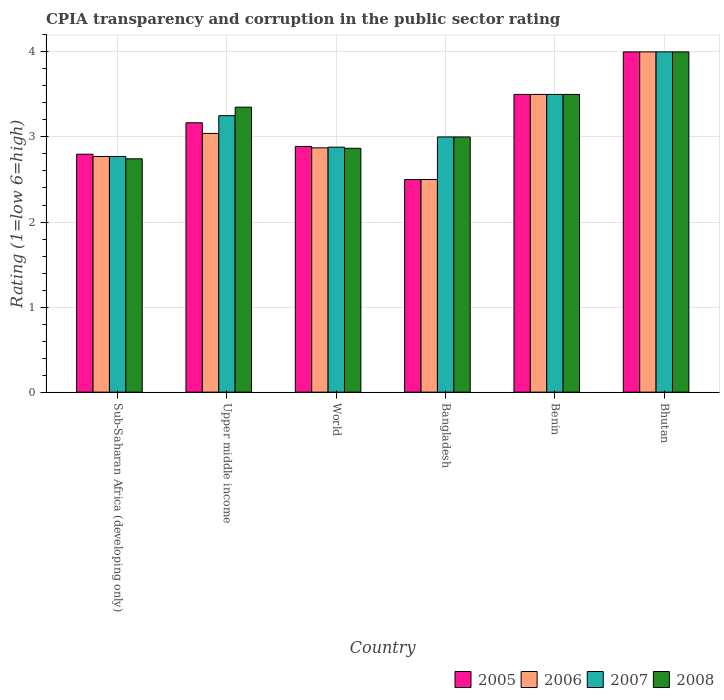How many different coloured bars are there?
Make the answer very short. 4. Are the number of bars per tick equal to the number of legend labels?
Your answer should be compact. Yes. How many bars are there on the 6th tick from the right?
Provide a succinct answer. 4. In how many cases, is the number of bars for a given country not equal to the number of legend labels?
Your response must be concise. 0. What is the CPIA rating in 2006 in World?
Your answer should be compact. 2.87. Across all countries, what is the minimum CPIA rating in 2006?
Your answer should be very brief. 2.5. In which country was the CPIA rating in 2006 maximum?
Your answer should be very brief. Bhutan. In which country was the CPIA rating in 2008 minimum?
Give a very brief answer. Sub-Saharan Africa (developing only). What is the total CPIA rating in 2007 in the graph?
Make the answer very short. 19.4. What is the difference between the CPIA rating in 2007 in Benin and that in Sub-Saharan Africa (developing only)?
Your answer should be very brief. 0.73. What is the average CPIA rating in 2006 per country?
Keep it short and to the point. 3.11. What is the difference between the CPIA rating of/in 2005 and CPIA rating of/in 2007 in Sub-Saharan Africa (developing only)?
Offer a very short reply. 0.03. What is the ratio of the CPIA rating in 2007 in Bangladesh to that in Benin?
Offer a very short reply. 0.86. What is the difference between the highest and the second highest CPIA rating in 2005?
Ensure brevity in your answer.  -0.33. What is the difference between the highest and the lowest CPIA rating in 2007?
Offer a very short reply. 1.23. Is it the case that in every country, the sum of the CPIA rating in 2006 and CPIA rating in 2008 is greater than the sum of CPIA rating in 2007 and CPIA rating in 2005?
Your response must be concise. No. What does the 3rd bar from the right in Sub-Saharan Africa (developing only) represents?
Provide a succinct answer. 2006. What is the difference between two consecutive major ticks on the Y-axis?
Provide a succinct answer. 1. Does the graph contain any zero values?
Your answer should be very brief. No. What is the title of the graph?
Your answer should be compact. CPIA transparency and corruption in the public sector rating. What is the label or title of the X-axis?
Ensure brevity in your answer.  Country. What is the label or title of the Y-axis?
Provide a succinct answer. Rating (1=low 6=high). What is the Rating (1=low 6=high) of 2005 in Sub-Saharan Africa (developing only)?
Give a very brief answer. 2.8. What is the Rating (1=low 6=high) of 2006 in Sub-Saharan Africa (developing only)?
Give a very brief answer. 2.77. What is the Rating (1=low 6=high) in 2007 in Sub-Saharan Africa (developing only)?
Give a very brief answer. 2.77. What is the Rating (1=low 6=high) in 2008 in Sub-Saharan Africa (developing only)?
Provide a short and direct response. 2.74. What is the Rating (1=low 6=high) in 2005 in Upper middle income?
Offer a very short reply. 3.17. What is the Rating (1=low 6=high) of 2006 in Upper middle income?
Offer a very short reply. 3.04. What is the Rating (1=low 6=high) of 2007 in Upper middle income?
Ensure brevity in your answer.  3.25. What is the Rating (1=low 6=high) in 2008 in Upper middle income?
Provide a short and direct response. 3.35. What is the Rating (1=low 6=high) of 2005 in World?
Keep it short and to the point. 2.89. What is the Rating (1=low 6=high) of 2006 in World?
Your answer should be very brief. 2.87. What is the Rating (1=low 6=high) of 2007 in World?
Your answer should be very brief. 2.88. What is the Rating (1=low 6=high) of 2008 in World?
Offer a terse response. 2.87. What is the Rating (1=low 6=high) in 2006 in Bangladesh?
Provide a succinct answer. 2.5. What is the Rating (1=low 6=high) of 2006 in Benin?
Ensure brevity in your answer.  3.5. What is the Rating (1=low 6=high) in 2008 in Benin?
Offer a very short reply. 3.5. What is the Rating (1=low 6=high) in 2006 in Bhutan?
Give a very brief answer. 4. Across all countries, what is the maximum Rating (1=low 6=high) in 2005?
Offer a terse response. 4. Across all countries, what is the maximum Rating (1=low 6=high) of 2007?
Provide a short and direct response. 4. Across all countries, what is the minimum Rating (1=low 6=high) in 2005?
Make the answer very short. 2.5. Across all countries, what is the minimum Rating (1=low 6=high) of 2007?
Offer a terse response. 2.77. Across all countries, what is the minimum Rating (1=low 6=high) in 2008?
Your response must be concise. 2.74. What is the total Rating (1=low 6=high) of 2005 in the graph?
Ensure brevity in your answer.  18.85. What is the total Rating (1=low 6=high) of 2006 in the graph?
Ensure brevity in your answer.  18.68. What is the total Rating (1=low 6=high) of 2007 in the graph?
Keep it short and to the point. 19.4. What is the total Rating (1=low 6=high) in 2008 in the graph?
Keep it short and to the point. 19.46. What is the difference between the Rating (1=low 6=high) of 2005 in Sub-Saharan Africa (developing only) and that in Upper middle income?
Your answer should be compact. -0.37. What is the difference between the Rating (1=low 6=high) in 2006 in Sub-Saharan Africa (developing only) and that in Upper middle income?
Ensure brevity in your answer.  -0.27. What is the difference between the Rating (1=low 6=high) in 2007 in Sub-Saharan Africa (developing only) and that in Upper middle income?
Your answer should be compact. -0.48. What is the difference between the Rating (1=low 6=high) of 2008 in Sub-Saharan Africa (developing only) and that in Upper middle income?
Your response must be concise. -0.61. What is the difference between the Rating (1=low 6=high) in 2005 in Sub-Saharan Africa (developing only) and that in World?
Offer a terse response. -0.09. What is the difference between the Rating (1=low 6=high) in 2006 in Sub-Saharan Africa (developing only) and that in World?
Provide a short and direct response. -0.1. What is the difference between the Rating (1=low 6=high) in 2007 in Sub-Saharan Africa (developing only) and that in World?
Your answer should be compact. -0.11. What is the difference between the Rating (1=low 6=high) in 2008 in Sub-Saharan Africa (developing only) and that in World?
Your answer should be very brief. -0.12. What is the difference between the Rating (1=low 6=high) in 2005 in Sub-Saharan Africa (developing only) and that in Bangladesh?
Your answer should be very brief. 0.3. What is the difference between the Rating (1=low 6=high) in 2006 in Sub-Saharan Africa (developing only) and that in Bangladesh?
Your answer should be compact. 0.27. What is the difference between the Rating (1=low 6=high) in 2007 in Sub-Saharan Africa (developing only) and that in Bangladesh?
Provide a short and direct response. -0.23. What is the difference between the Rating (1=low 6=high) of 2008 in Sub-Saharan Africa (developing only) and that in Bangladesh?
Ensure brevity in your answer.  -0.26. What is the difference between the Rating (1=low 6=high) in 2005 in Sub-Saharan Africa (developing only) and that in Benin?
Your answer should be very brief. -0.7. What is the difference between the Rating (1=low 6=high) of 2006 in Sub-Saharan Africa (developing only) and that in Benin?
Provide a short and direct response. -0.73. What is the difference between the Rating (1=low 6=high) of 2007 in Sub-Saharan Africa (developing only) and that in Benin?
Give a very brief answer. -0.73. What is the difference between the Rating (1=low 6=high) of 2008 in Sub-Saharan Africa (developing only) and that in Benin?
Your answer should be compact. -0.76. What is the difference between the Rating (1=low 6=high) of 2005 in Sub-Saharan Africa (developing only) and that in Bhutan?
Your answer should be very brief. -1.2. What is the difference between the Rating (1=low 6=high) of 2006 in Sub-Saharan Africa (developing only) and that in Bhutan?
Provide a succinct answer. -1.23. What is the difference between the Rating (1=low 6=high) of 2007 in Sub-Saharan Africa (developing only) and that in Bhutan?
Keep it short and to the point. -1.23. What is the difference between the Rating (1=low 6=high) in 2008 in Sub-Saharan Africa (developing only) and that in Bhutan?
Your response must be concise. -1.26. What is the difference between the Rating (1=low 6=high) in 2005 in Upper middle income and that in World?
Ensure brevity in your answer.  0.28. What is the difference between the Rating (1=low 6=high) in 2006 in Upper middle income and that in World?
Your response must be concise. 0.17. What is the difference between the Rating (1=low 6=high) of 2007 in Upper middle income and that in World?
Keep it short and to the point. 0.37. What is the difference between the Rating (1=low 6=high) in 2008 in Upper middle income and that in World?
Provide a succinct answer. 0.48. What is the difference between the Rating (1=low 6=high) in 2005 in Upper middle income and that in Bangladesh?
Keep it short and to the point. 0.67. What is the difference between the Rating (1=low 6=high) in 2006 in Upper middle income and that in Bangladesh?
Your response must be concise. 0.54. What is the difference between the Rating (1=low 6=high) in 2007 in Upper middle income and that in Bangladesh?
Provide a short and direct response. 0.25. What is the difference between the Rating (1=low 6=high) in 2008 in Upper middle income and that in Bangladesh?
Offer a terse response. 0.35. What is the difference between the Rating (1=low 6=high) of 2006 in Upper middle income and that in Benin?
Offer a terse response. -0.46. What is the difference between the Rating (1=low 6=high) of 2006 in Upper middle income and that in Bhutan?
Give a very brief answer. -0.96. What is the difference between the Rating (1=low 6=high) of 2007 in Upper middle income and that in Bhutan?
Provide a succinct answer. -0.75. What is the difference between the Rating (1=low 6=high) in 2008 in Upper middle income and that in Bhutan?
Make the answer very short. -0.65. What is the difference between the Rating (1=low 6=high) of 2005 in World and that in Bangladesh?
Ensure brevity in your answer.  0.39. What is the difference between the Rating (1=low 6=high) of 2006 in World and that in Bangladesh?
Your response must be concise. 0.37. What is the difference between the Rating (1=low 6=high) of 2007 in World and that in Bangladesh?
Provide a succinct answer. -0.12. What is the difference between the Rating (1=low 6=high) of 2008 in World and that in Bangladesh?
Provide a short and direct response. -0.13. What is the difference between the Rating (1=low 6=high) in 2005 in World and that in Benin?
Offer a very short reply. -0.61. What is the difference between the Rating (1=low 6=high) in 2006 in World and that in Benin?
Provide a short and direct response. -0.63. What is the difference between the Rating (1=low 6=high) of 2007 in World and that in Benin?
Offer a very short reply. -0.62. What is the difference between the Rating (1=low 6=high) of 2008 in World and that in Benin?
Give a very brief answer. -0.63. What is the difference between the Rating (1=low 6=high) in 2005 in World and that in Bhutan?
Ensure brevity in your answer.  -1.11. What is the difference between the Rating (1=low 6=high) of 2006 in World and that in Bhutan?
Give a very brief answer. -1.13. What is the difference between the Rating (1=low 6=high) in 2007 in World and that in Bhutan?
Give a very brief answer. -1.12. What is the difference between the Rating (1=low 6=high) in 2008 in World and that in Bhutan?
Ensure brevity in your answer.  -1.13. What is the difference between the Rating (1=low 6=high) in 2005 in Bangladesh and that in Benin?
Make the answer very short. -1. What is the difference between the Rating (1=low 6=high) in 2006 in Bangladesh and that in Benin?
Offer a terse response. -1. What is the difference between the Rating (1=low 6=high) of 2007 in Bangladesh and that in Benin?
Offer a terse response. -0.5. What is the difference between the Rating (1=low 6=high) in 2008 in Bangladesh and that in Benin?
Ensure brevity in your answer.  -0.5. What is the difference between the Rating (1=low 6=high) of 2008 in Bangladesh and that in Bhutan?
Offer a very short reply. -1. What is the difference between the Rating (1=low 6=high) in 2006 in Benin and that in Bhutan?
Offer a very short reply. -0.5. What is the difference between the Rating (1=low 6=high) of 2008 in Benin and that in Bhutan?
Give a very brief answer. -0.5. What is the difference between the Rating (1=low 6=high) in 2005 in Sub-Saharan Africa (developing only) and the Rating (1=low 6=high) in 2006 in Upper middle income?
Provide a succinct answer. -0.24. What is the difference between the Rating (1=low 6=high) of 2005 in Sub-Saharan Africa (developing only) and the Rating (1=low 6=high) of 2007 in Upper middle income?
Your answer should be compact. -0.45. What is the difference between the Rating (1=low 6=high) in 2005 in Sub-Saharan Africa (developing only) and the Rating (1=low 6=high) in 2008 in Upper middle income?
Your answer should be very brief. -0.55. What is the difference between the Rating (1=low 6=high) in 2006 in Sub-Saharan Africa (developing only) and the Rating (1=low 6=high) in 2007 in Upper middle income?
Your response must be concise. -0.48. What is the difference between the Rating (1=low 6=high) in 2006 in Sub-Saharan Africa (developing only) and the Rating (1=low 6=high) in 2008 in Upper middle income?
Make the answer very short. -0.58. What is the difference between the Rating (1=low 6=high) in 2007 in Sub-Saharan Africa (developing only) and the Rating (1=low 6=high) in 2008 in Upper middle income?
Ensure brevity in your answer.  -0.58. What is the difference between the Rating (1=low 6=high) in 2005 in Sub-Saharan Africa (developing only) and the Rating (1=low 6=high) in 2006 in World?
Ensure brevity in your answer.  -0.07. What is the difference between the Rating (1=low 6=high) of 2005 in Sub-Saharan Africa (developing only) and the Rating (1=low 6=high) of 2007 in World?
Make the answer very short. -0.08. What is the difference between the Rating (1=low 6=high) in 2005 in Sub-Saharan Africa (developing only) and the Rating (1=low 6=high) in 2008 in World?
Your answer should be very brief. -0.07. What is the difference between the Rating (1=low 6=high) in 2006 in Sub-Saharan Africa (developing only) and the Rating (1=low 6=high) in 2007 in World?
Offer a terse response. -0.11. What is the difference between the Rating (1=low 6=high) in 2006 in Sub-Saharan Africa (developing only) and the Rating (1=low 6=high) in 2008 in World?
Provide a succinct answer. -0.1. What is the difference between the Rating (1=low 6=high) of 2007 in Sub-Saharan Africa (developing only) and the Rating (1=low 6=high) of 2008 in World?
Your answer should be compact. -0.1. What is the difference between the Rating (1=low 6=high) of 2005 in Sub-Saharan Africa (developing only) and the Rating (1=low 6=high) of 2006 in Bangladesh?
Keep it short and to the point. 0.3. What is the difference between the Rating (1=low 6=high) of 2005 in Sub-Saharan Africa (developing only) and the Rating (1=low 6=high) of 2007 in Bangladesh?
Ensure brevity in your answer.  -0.2. What is the difference between the Rating (1=low 6=high) in 2005 in Sub-Saharan Africa (developing only) and the Rating (1=low 6=high) in 2008 in Bangladesh?
Give a very brief answer. -0.2. What is the difference between the Rating (1=low 6=high) in 2006 in Sub-Saharan Africa (developing only) and the Rating (1=low 6=high) in 2007 in Bangladesh?
Your answer should be compact. -0.23. What is the difference between the Rating (1=low 6=high) of 2006 in Sub-Saharan Africa (developing only) and the Rating (1=low 6=high) of 2008 in Bangladesh?
Provide a succinct answer. -0.23. What is the difference between the Rating (1=low 6=high) in 2007 in Sub-Saharan Africa (developing only) and the Rating (1=low 6=high) in 2008 in Bangladesh?
Give a very brief answer. -0.23. What is the difference between the Rating (1=low 6=high) in 2005 in Sub-Saharan Africa (developing only) and the Rating (1=low 6=high) in 2006 in Benin?
Your response must be concise. -0.7. What is the difference between the Rating (1=low 6=high) in 2005 in Sub-Saharan Africa (developing only) and the Rating (1=low 6=high) in 2007 in Benin?
Offer a terse response. -0.7. What is the difference between the Rating (1=low 6=high) in 2005 in Sub-Saharan Africa (developing only) and the Rating (1=low 6=high) in 2008 in Benin?
Offer a very short reply. -0.7. What is the difference between the Rating (1=low 6=high) in 2006 in Sub-Saharan Africa (developing only) and the Rating (1=low 6=high) in 2007 in Benin?
Your response must be concise. -0.73. What is the difference between the Rating (1=low 6=high) of 2006 in Sub-Saharan Africa (developing only) and the Rating (1=low 6=high) of 2008 in Benin?
Provide a short and direct response. -0.73. What is the difference between the Rating (1=low 6=high) of 2007 in Sub-Saharan Africa (developing only) and the Rating (1=low 6=high) of 2008 in Benin?
Provide a succinct answer. -0.73. What is the difference between the Rating (1=low 6=high) in 2005 in Sub-Saharan Africa (developing only) and the Rating (1=low 6=high) in 2006 in Bhutan?
Give a very brief answer. -1.2. What is the difference between the Rating (1=low 6=high) in 2005 in Sub-Saharan Africa (developing only) and the Rating (1=low 6=high) in 2007 in Bhutan?
Offer a terse response. -1.2. What is the difference between the Rating (1=low 6=high) in 2005 in Sub-Saharan Africa (developing only) and the Rating (1=low 6=high) in 2008 in Bhutan?
Your answer should be compact. -1.2. What is the difference between the Rating (1=low 6=high) of 2006 in Sub-Saharan Africa (developing only) and the Rating (1=low 6=high) of 2007 in Bhutan?
Your response must be concise. -1.23. What is the difference between the Rating (1=low 6=high) in 2006 in Sub-Saharan Africa (developing only) and the Rating (1=low 6=high) in 2008 in Bhutan?
Give a very brief answer. -1.23. What is the difference between the Rating (1=low 6=high) of 2007 in Sub-Saharan Africa (developing only) and the Rating (1=low 6=high) of 2008 in Bhutan?
Provide a succinct answer. -1.23. What is the difference between the Rating (1=low 6=high) in 2005 in Upper middle income and the Rating (1=low 6=high) in 2006 in World?
Keep it short and to the point. 0.29. What is the difference between the Rating (1=low 6=high) in 2005 in Upper middle income and the Rating (1=low 6=high) in 2007 in World?
Give a very brief answer. 0.29. What is the difference between the Rating (1=low 6=high) of 2006 in Upper middle income and the Rating (1=low 6=high) of 2007 in World?
Offer a very short reply. 0.16. What is the difference between the Rating (1=low 6=high) of 2006 in Upper middle income and the Rating (1=low 6=high) of 2008 in World?
Your response must be concise. 0.17. What is the difference between the Rating (1=low 6=high) of 2007 in Upper middle income and the Rating (1=low 6=high) of 2008 in World?
Ensure brevity in your answer.  0.38. What is the difference between the Rating (1=low 6=high) of 2005 in Upper middle income and the Rating (1=low 6=high) of 2006 in Bangladesh?
Make the answer very short. 0.67. What is the difference between the Rating (1=low 6=high) in 2005 in Upper middle income and the Rating (1=low 6=high) in 2008 in Bangladesh?
Offer a terse response. 0.17. What is the difference between the Rating (1=low 6=high) in 2006 in Upper middle income and the Rating (1=low 6=high) in 2007 in Bangladesh?
Your answer should be very brief. 0.04. What is the difference between the Rating (1=low 6=high) in 2006 in Upper middle income and the Rating (1=low 6=high) in 2008 in Bangladesh?
Provide a succinct answer. 0.04. What is the difference between the Rating (1=low 6=high) of 2007 in Upper middle income and the Rating (1=low 6=high) of 2008 in Bangladesh?
Offer a very short reply. 0.25. What is the difference between the Rating (1=low 6=high) in 2005 in Upper middle income and the Rating (1=low 6=high) in 2006 in Benin?
Your answer should be compact. -0.33. What is the difference between the Rating (1=low 6=high) in 2005 in Upper middle income and the Rating (1=low 6=high) in 2007 in Benin?
Offer a terse response. -0.33. What is the difference between the Rating (1=low 6=high) in 2006 in Upper middle income and the Rating (1=low 6=high) in 2007 in Benin?
Provide a short and direct response. -0.46. What is the difference between the Rating (1=low 6=high) of 2006 in Upper middle income and the Rating (1=low 6=high) of 2008 in Benin?
Offer a terse response. -0.46. What is the difference between the Rating (1=low 6=high) of 2005 in Upper middle income and the Rating (1=low 6=high) of 2006 in Bhutan?
Offer a terse response. -0.83. What is the difference between the Rating (1=low 6=high) in 2005 in Upper middle income and the Rating (1=low 6=high) in 2008 in Bhutan?
Offer a terse response. -0.83. What is the difference between the Rating (1=low 6=high) of 2006 in Upper middle income and the Rating (1=low 6=high) of 2007 in Bhutan?
Your answer should be compact. -0.96. What is the difference between the Rating (1=low 6=high) in 2006 in Upper middle income and the Rating (1=low 6=high) in 2008 in Bhutan?
Offer a terse response. -0.96. What is the difference between the Rating (1=low 6=high) in 2007 in Upper middle income and the Rating (1=low 6=high) in 2008 in Bhutan?
Offer a terse response. -0.75. What is the difference between the Rating (1=low 6=high) of 2005 in World and the Rating (1=low 6=high) of 2006 in Bangladesh?
Provide a succinct answer. 0.39. What is the difference between the Rating (1=low 6=high) in 2005 in World and the Rating (1=low 6=high) in 2007 in Bangladesh?
Offer a terse response. -0.11. What is the difference between the Rating (1=low 6=high) in 2005 in World and the Rating (1=low 6=high) in 2008 in Bangladesh?
Offer a terse response. -0.11. What is the difference between the Rating (1=low 6=high) of 2006 in World and the Rating (1=low 6=high) of 2007 in Bangladesh?
Provide a succinct answer. -0.13. What is the difference between the Rating (1=low 6=high) of 2006 in World and the Rating (1=low 6=high) of 2008 in Bangladesh?
Ensure brevity in your answer.  -0.13. What is the difference between the Rating (1=low 6=high) in 2007 in World and the Rating (1=low 6=high) in 2008 in Bangladesh?
Keep it short and to the point. -0.12. What is the difference between the Rating (1=low 6=high) of 2005 in World and the Rating (1=low 6=high) of 2006 in Benin?
Your response must be concise. -0.61. What is the difference between the Rating (1=low 6=high) of 2005 in World and the Rating (1=low 6=high) of 2007 in Benin?
Offer a terse response. -0.61. What is the difference between the Rating (1=low 6=high) in 2005 in World and the Rating (1=low 6=high) in 2008 in Benin?
Give a very brief answer. -0.61. What is the difference between the Rating (1=low 6=high) in 2006 in World and the Rating (1=low 6=high) in 2007 in Benin?
Offer a terse response. -0.63. What is the difference between the Rating (1=low 6=high) of 2006 in World and the Rating (1=low 6=high) of 2008 in Benin?
Provide a short and direct response. -0.63. What is the difference between the Rating (1=low 6=high) in 2007 in World and the Rating (1=low 6=high) in 2008 in Benin?
Keep it short and to the point. -0.62. What is the difference between the Rating (1=low 6=high) in 2005 in World and the Rating (1=low 6=high) in 2006 in Bhutan?
Give a very brief answer. -1.11. What is the difference between the Rating (1=low 6=high) in 2005 in World and the Rating (1=low 6=high) in 2007 in Bhutan?
Offer a terse response. -1.11. What is the difference between the Rating (1=low 6=high) of 2005 in World and the Rating (1=low 6=high) of 2008 in Bhutan?
Offer a very short reply. -1.11. What is the difference between the Rating (1=low 6=high) in 2006 in World and the Rating (1=low 6=high) in 2007 in Bhutan?
Provide a succinct answer. -1.13. What is the difference between the Rating (1=low 6=high) in 2006 in World and the Rating (1=low 6=high) in 2008 in Bhutan?
Provide a succinct answer. -1.13. What is the difference between the Rating (1=low 6=high) of 2007 in World and the Rating (1=low 6=high) of 2008 in Bhutan?
Offer a terse response. -1.12. What is the difference between the Rating (1=low 6=high) in 2005 in Bangladesh and the Rating (1=low 6=high) in 2006 in Benin?
Give a very brief answer. -1. What is the difference between the Rating (1=low 6=high) in 2006 in Bangladesh and the Rating (1=low 6=high) in 2007 in Benin?
Provide a short and direct response. -1. What is the difference between the Rating (1=low 6=high) in 2005 in Bangladesh and the Rating (1=low 6=high) in 2007 in Bhutan?
Keep it short and to the point. -1.5. What is the difference between the Rating (1=low 6=high) in 2006 in Bangladesh and the Rating (1=low 6=high) in 2007 in Bhutan?
Your answer should be compact. -1.5. What is the difference between the Rating (1=low 6=high) of 2006 in Bangladesh and the Rating (1=low 6=high) of 2008 in Bhutan?
Provide a short and direct response. -1.5. What is the difference between the Rating (1=low 6=high) of 2005 in Benin and the Rating (1=low 6=high) of 2006 in Bhutan?
Your answer should be very brief. -0.5. What is the difference between the Rating (1=low 6=high) of 2005 in Benin and the Rating (1=low 6=high) of 2007 in Bhutan?
Provide a short and direct response. -0.5. What is the difference between the Rating (1=low 6=high) in 2005 in Benin and the Rating (1=low 6=high) in 2008 in Bhutan?
Give a very brief answer. -0.5. What is the difference between the Rating (1=low 6=high) in 2006 in Benin and the Rating (1=low 6=high) in 2007 in Bhutan?
Offer a very short reply. -0.5. What is the difference between the Rating (1=low 6=high) in 2006 in Benin and the Rating (1=low 6=high) in 2008 in Bhutan?
Provide a short and direct response. -0.5. What is the difference between the Rating (1=low 6=high) of 2007 in Benin and the Rating (1=low 6=high) of 2008 in Bhutan?
Keep it short and to the point. -0.5. What is the average Rating (1=low 6=high) in 2005 per country?
Offer a terse response. 3.14. What is the average Rating (1=low 6=high) of 2006 per country?
Offer a terse response. 3.11. What is the average Rating (1=low 6=high) of 2007 per country?
Give a very brief answer. 3.23. What is the average Rating (1=low 6=high) of 2008 per country?
Give a very brief answer. 3.24. What is the difference between the Rating (1=low 6=high) of 2005 and Rating (1=low 6=high) of 2006 in Sub-Saharan Africa (developing only)?
Give a very brief answer. 0.03. What is the difference between the Rating (1=low 6=high) of 2005 and Rating (1=low 6=high) of 2007 in Sub-Saharan Africa (developing only)?
Your answer should be compact. 0.03. What is the difference between the Rating (1=low 6=high) in 2005 and Rating (1=low 6=high) in 2008 in Sub-Saharan Africa (developing only)?
Keep it short and to the point. 0.05. What is the difference between the Rating (1=low 6=high) of 2006 and Rating (1=low 6=high) of 2007 in Sub-Saharan Africa (developing only)?
Your answer should be very brief. 0. What is the difference between the Rating (1=low 6=high) of 2006 and Rating (1=low 6=high) of 2008 in Sub-Saharan Africa (developing only)?
Keep it short and to the point. 0.03. What is the difference between the Rating (1=low 6=high) in 2007 and Rating (1=low 6=high) in 2008 in Sub-Saharan Africa (developing only)?
Offer a very short reply. 0.03. What is the difference between the Rating (1=low 6=high) of 2005 and Rating (1=low 6=high) of 2007 in Upper middle income?
Give a very brief answer. -0.08. What is the difference between the Rating (1=low 6=high) of 2005 and Rating (1=low 6=high) of 2008 in Upper middle income?
Offer a terse response. -0.18. What is the difference between the Rating (1=low 6=high) of 2006 and Rating (1=low 6=high) of 2007 in Upper middle income?
Provide a short and direct response. -0.21. What is the difference between the Rating (1=low 6=high) in 2006 and Rating (1=low 6=high) in 2008 in Upper middle income?
Provide a short and direct response. -0.31. What is the difference between the Rating (1=low 6=high) of 2005 and Rating (1=low 6=high) of 2006 in World?
Offer a very short reply. 0.02. What is the difference between the Rating (1=low 6=high) in 2005 and Rating (1=low 6=high) in 2007 in World?
Provide a short and direct response. 0.01. What is the difference between the Rating (1=low 6=high) of 2005 and Rating (1=low 6=high) of 2008 in World?
Your response must be concise. 0.02. What is the difference between the Rating (1=low 6=high) in 2006 and Rating (1=low 6=high) in 2007 in World?
Keep it short and to the point. -0.01. What is the difference between the Rating (1=low 6=high) of 2006 and Rating (1=low 6=high) of 2008 in World?
Provide a short and direct response. 0.01. What is the difference between the Rating (1=low 6=high) of 2007 and Rating (1=low 6=high) of 2008 in World?
Offer a terse response. 0.01. What is the difference between the Rating (1=low 6=high) in 2005 and Rating (1=low 6=high) in 2006 in Bangladesh?
Ensure brevity in your answer.  0. What is the difference between the Rating (1=low 6=high) in 2005 and Rating (1=low 6=high) in 2007 in Bangladesh?
Provide a succinct answer. -0.5. What is the difference between the Rating (1=low 6=high) in 2005 and Rating (1=low 6=high) in 2008 in Bangladesh?
Keep it short and to the point. -0.5. What is the difference between the Rating (1=low 6=high) in 2006 and Rating (1=low 6=high) in 2007 in Bangladesh?
Ensure brevity in your answer.  -0.5. What is the difference between the Rating (1=low 6=high) in 2007 and Rating (1=low 6=high) in 2008 in Bangladesh?
Ensure brevity in your answer.  0. What is the difference between the Rating (1=low 6=high) in 2005 and Rating (1=low 6=high) in 2006 in Benin?
Offer a very short reply. 0. What is the difference between the Rating (1=low 6=high) of 2005 and Rating (1=low 6=high) of 2008 in Bhutan?
Your response must be concise. 0. What is the difference between the Rating (1=low 6=high) in 2006 and Rating (1=low 6=high) in 2007 in Bhutan?
Your answer should be very brief. 0. What is the ratio of the Rating (1=low 6=high) of 2005 in Sub-Saharan Africa (developing only) to that in Upper middle income?
Offer a very short reply. 0.88. What is the ratio of the Rating (1=low 6=high) of 2006 in Sub-Saharan Africa (developing only) to that in Upper middle income?
Provide a short and direct response. 0.91. What is the ratio of the Rating (1=low 6=high) of 2007 in Sub-Saharan Africa (developing only) to that in Upper middle income?
Provide a short and direct response. 0.85. What is the ratio of the Rating (1=low 6=high) in 2008 in Sub-Saharan Africa (developing only) to that in Upper middle income?
Your answer should be very brief. 0.82. What is the ratio of the Rating (1=low 6=high) in 2005 in Sub-Saharan Africa (developing only) to that in World?
Your response must be concise. 0.97. What is the ratio of the Rating (1=low 6=high) of 2006 in Sub-Saharan Africa (developing only) to that in World?
Ensure brevity in your answer.  0.96. What is the ratio of the Rating (1=low 6=high) in 2007 in Sub-Saharan Africa (developing only) to that in World?
Your answer should be very brief. 0.96. What is the ratio of the Rating (1=low 6=high) of 2008 in Sub-Saharan Africa (developing only) to that in World?
Keep it short and to the point. 0.96. What is the ratio of the Rating (1=low 6=high) of 2005 in Sub-Saharan Africa (developing only) to that in Bangladesh?
Keep it short and to the point. 1.12. What is the ratio of the Rating (1=low 6=high) in 2006 in Sub-Saharan Africa (developing only) to that in Bangladesh?
Offer a terse response. 1.11. What is the ratio of the Rating (1=low 6=high) in 2007 in Sub-Saharan Africa (developing only) to that in Bangladesh?
Give a very brief answer. 0.92. What is the ratio of the Rating (1=low 6=high) in 2008 in Sub-Saharan Africa (developing only) to that in Bangladesh?
Give a very brief answer. 0.91. What is the ratio of the Rating (1=low 6=high) of 2005 in Sub-Saharan Africa (developing only) to that in Benin?
Ensure brevity in your answer.  0.8. What is the ratio of the Rating (1=low 6=high) in 2006 in Sub-Saharan Africa (developing only) to that in Benin?
Offer a very short reply. 0.79. What is the ratio of the Rating (1=low 6=high) of 2007 in Sub-Saharan Africa (developing only) to that in Benin?
Provide a short and direct response. 0.79. What is the ratio of the Rating (1=low 6=high) in 2008 in Sub-Saharan Africa (developing only) to that in Benin?
Provide a short and direct response. 0.78. What is the ratio of the Rating (1=low 6=high) of 2005 in Sub-Saharan Africa (developing only) to that in Bhutan?
Give a very brief answer. 0.7. What is the ratio of the Rating (1=low 6=high) of 2006 in Sub-Saharan Africa (developing only) to that in Bhutan?
Offer a very short reply. 0.69. What is the ratio of the Rating (1=low 6=high) of 2007 in Sub-Saharan Africa (developing only) to that in Bhutan?
Offer a very short reply. 0.69. What is the ratio of the Rating (1=low 6=high) in 2008 in Sub-Saharan Africa (developing only) to that in Bhutan?
Your answer should be compact. 0.69. What is the ratio of the Rating (1=low 6=high) of 2005 in Upper middle income to that in World?
Ensure brevity in your answer.  1.1. What is the ratio of the Rating (1=low 6=high) in 2006 in Upper middle income to that in World?
Offer a terse response. 1.06. What is the ratio of the Rating (1=low 6=high) of 2007 in Upper middle income to that in World?
Ensure brevity in your answer.  1.13. What is the ratio of the Rating (1=low 6=high) in 2008 in Upper middle income to that in World?
Your answer should be very brief. 1.17. What is the ratio of the Rating (1=low 6=high) in 2005 in Upper middle income to that in Bangladesh?
Your response must be concise. 1.27. What is the ratio of the Rating (1=low 6=high) in 2006 in Upper middle income to that in Bangladesh?
Offer a very short reply. 1.22. What is the ratio of the Rating (1=low 6=high) of 2007 in Upper middle income to that in Bangladesh?
Make the answer very short. 1.08. What is the ratio of the Rating (1=low 6=high) in 2008 in Upper middle income to that in Bangladesh?
Keep it short and to the point. 1.12. What is the ratio of the Rating (1=low 6=high) in 2005 in Upper middle income to that in Benin?
Keep it short and to the point. 0.9. What is the ratio of the Rating (1=low 6=high) of 2006 in Upper middle income to that in Benin?
Provide a succinct answer. 0.87. What is the ratio of the Rating (1=low 6=high) of 2007 in Upper middle income to that in Benin?
Ensure brevity in your answer.  0.93. What is the ratio of the Rating (1=low 6=high) in 2008 in Upper middle income to that in Benin?
Ensure brevity in your answer.  0.96. What is the ratio of the Rating (1=low 6=high) of 2005 in Upper middle income to that in Bhutan?
Your answer should be very brief. 0.79. What is the ratio of the Rating (1=low 6=high) of 2006 in Upper middle income to that in Bhutan?
Provide a succinct answer. 0.76. What is the ratio of the Rating (1=low 6=high) of 2007 in Upper middle income to that in Bhutan?
Give a very brief answer. 0.81. What is the ratio of the Rating (1=low 6=high) of 2008 in Upper middle income to that in Bhutan?
Your answer should be compact. 0.84. What is the ratio of the Rating (1=low 6=high) in 2005 in World to that in Bangladesh?
Your response must be concise. 1.16. What is the ratio of the Rating (1=low 6=high) of 2006 in World to that in Bangladesh?
Your answer should be compact. 1.15. What is the ratio of the Rating (1=low 6=high) of 2007 in World to that in Bangladesh?
Offer a very short reply. 0.96. What is the ratio of the Rating (1=low 6=high) in 2008 in World to that in Bangladesh?
Give a very brief answer. 0.96. What is the ratio of the Rating (1=low 6=high) of 2005 in World to that in Benin?
Provide a succinct answer. 0.83. What is the ratio of the Rating (1=low 6=high) of 2006 in World to that in Benin?
Your answer should be compact. 0.82. What is the ratio of the Rating (1=low 6=high) of 2007 in World to that in Benin?
Offer a very short reply. 0.82. What is the ratio of the Rating (1=low 6=high) in 2008 in World to that in Benin?
Make the answer very short. 0.82. What is the ratio of the Rating (1=low 6=high) of 2005 in World to that in Bhutan?
Your answer should be very brief. 0.72. What is the ratio of the Rating (1=low 6=high) of 2006 in World to that in Bhutan?
Give a very brief answer. 0.72. What is the ratio of the Rating (1=low 6=high) in 2007 in World to that in Bhutan?
Make the answer very short. 0.72. What is the ratio of the Rating (1=low 6=high) in 2008 in World to that in Bhutan?
Your answer should be very brief. 0.72. What is the ratio of the Rating (1=low 6=high) in 2005 in Bangladesh to that in Benin?
Your answer should be very brief. 0.71. What is the ratio of the Rating (1=low 6=high) of 2006 in Bangladesh to that in Benin?
Ensure brevity in your answer.  0.71. What is the ratio of the Rating (1=low 6=high) in 2007 in Bangladesh to that in Benin?
Provide a succinct answer. 0.86. What is the ratio of the Rating (1=low 6=high) of 2008 in Bangladesh to that in Benin?
Give a very brief answer. 0.86. What is the ratio of the Rating (1=low 6=high) of 2005 in Bangladesh to that in Bhutan?
Your answer should be compact. 0.62. What is the ratio of the Rating (1=low 6=high) in 2006 in Bangladesh to that in Bhutan?
Your response must be concise. 0.62. What is the ratio of the Rating (1=low 6=high) of 2006 in Benin to that in Bhutan?
Your answer should be very brief. 0.88. What is the ratio of the Rating (1=low 6=high) of 2007 in Benin to that in Bhutan?
Offer a very short reply. 0.88. What is the difference between the highest and the second highest Rating (1=low 6=high) in 2007?
Offer a very short reply. 0.5. What is the difference between the highest and the lowest Rating (1=low 6=high) of 2007?
Offer a terse response. 1.23. What is the difference between the highest and the lowest Rating (1=low 6=high) of 2008?
Your answer should be compact. 1.26. 